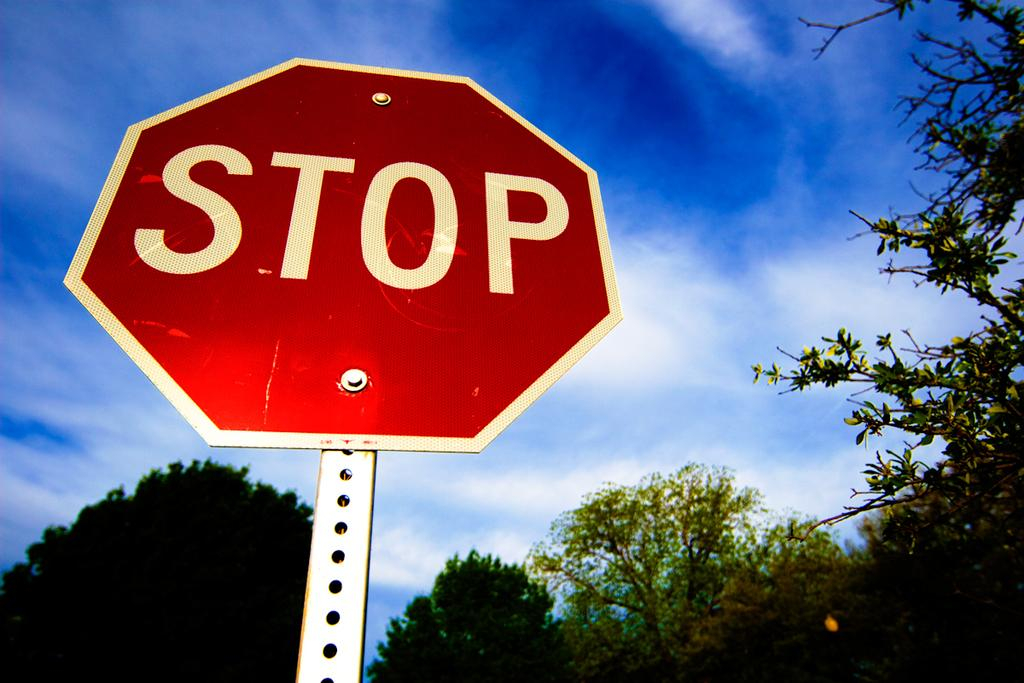<image>
Share a concise interpretation of the image provided. A Stop Sign against the background of a beautiful blue sky. 